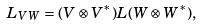Convert formula to latex. <formula><loc_0><loc_0><loc_500><loc_500>L _ { V W } = ( V \otimes V ^ { * } ) L ( W \otimes W ^ { * } ) ,</formula> 